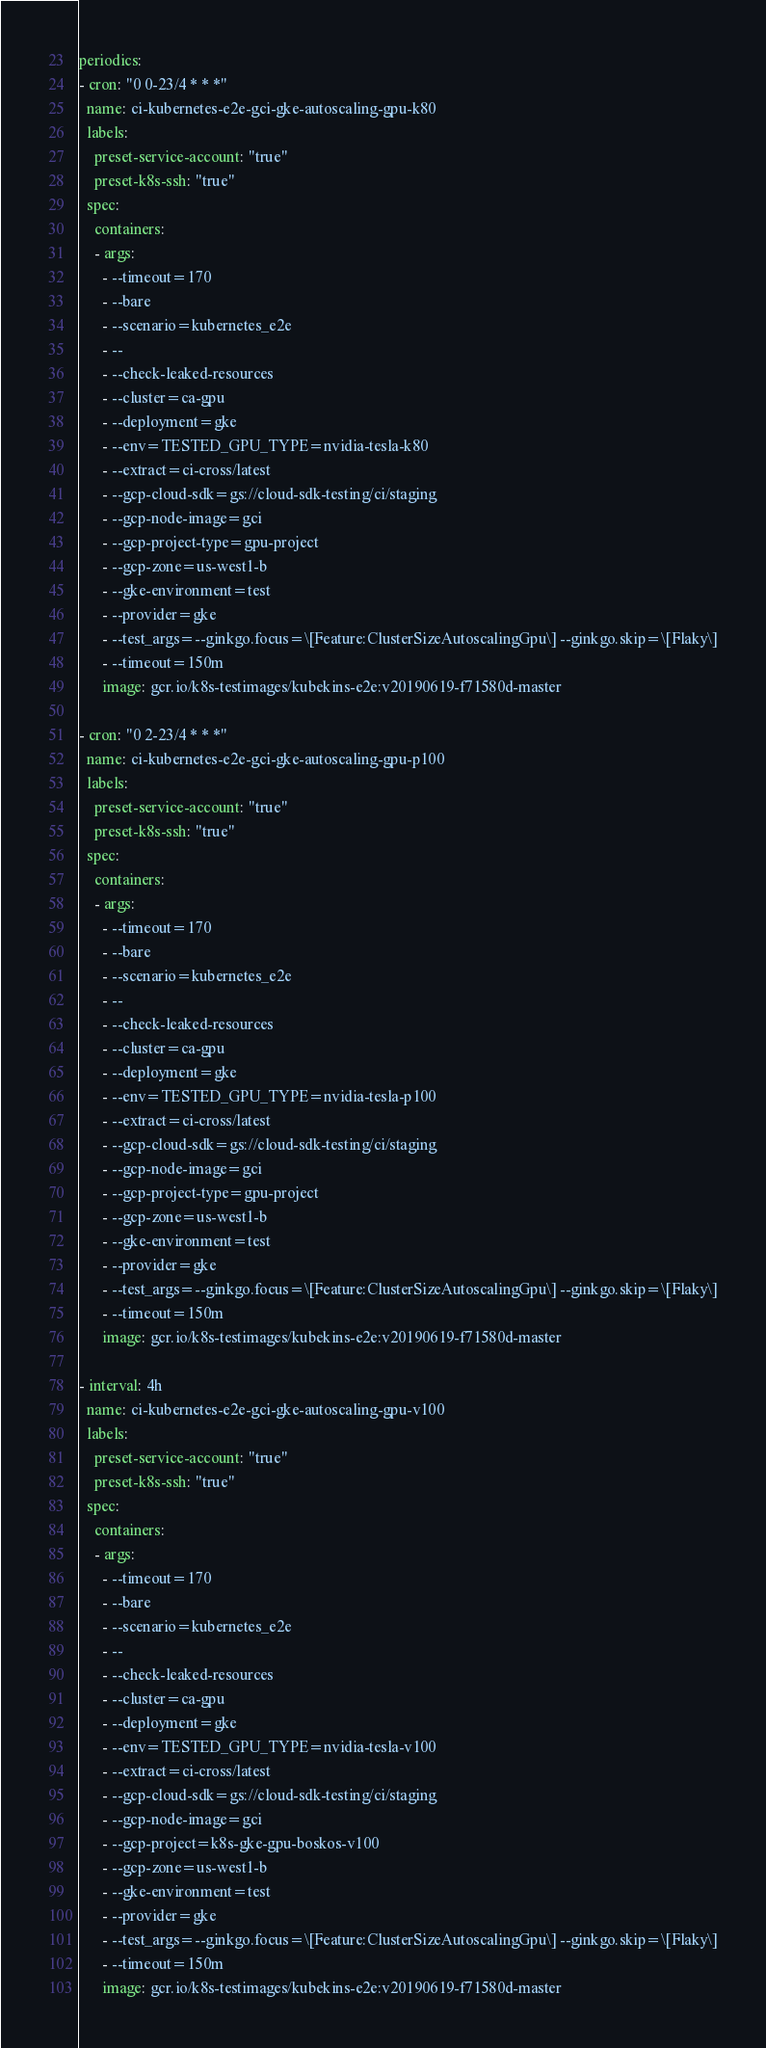<code> <loc_0><loc_0><loc_500><loc_500><_YAML_>periodics:
- cron: "0 0-23/4 * * *"
  name: ci-kubernetes-e2e-gci-gke-autoscaling-gpu-k80
  labels:
    preset-service-account: "true"
    preset-k8s-ssh: "true"
  spec:
    containers:
    - args:
      - --timeout=170
      - --bare
      - --scenario=kubernetes_e2e
      - --
      - --check-leaked-resources
      - --cluster=ca-gpu
      - --deployment=gke
      - --env=TESTED_GPU_TYPE=nvidia-tesla-k80
      - --extract=ci-cross/latest
      - --gcp-cloud-sdk=gs://cloud-sdk-testing/ci/staging
      - --gcp-node-image=gci
      - --gcp-project-type=gpu-project
      - --gcp-zone=us-west1-b
      - --gke-environment=test
      - --provider=gke
      - --test_args=--ginkgo.focus=\[Feature:ClusterSizeAutoscalingGpu\] --ginkgo.skip=\[Flaky\]
      - --timeout=150m
      image: gcr.io/k8s-testimages/kubekins-e2e:v20190619-f71580d-master

- cron: "0 2-23/4 * * *"
  name: ci-kubernetes-e2e-gci-gke-autoscaling-gpu-p100
  labels:
    preset-service-account: "true"
    preset-k8s-ssh: "true"
  spec:
    containers:
    - args:
      - --timeout=170
      - --bare
      - --scenario=kubernetes_e2e
      - --
      - --check-leaked-resources
      - --cluster=ca-gpu
      - --deployment=gke
      - --env=TESTED_GPU_TYPE=nvidia-tesla-p100
      - --extract=ci-cross/latest
      - --gcp-cloud-sdk=gs://cloud-sdk-testing/ci/staging
      - --gcp-node-image=gci
      - --gcp-project-type=gpu-project
      - --gcp-zone=us-west1-b
      - --gke-environment=test
      - --provider=gke
      - --test_args=--ginkgo.focus=\[Feature:ClusterSizeAutoscalingGpu\] --ginkgo.skip=\[Flaky\]
      - --timeout=150m
      image: gcr.io/k8s-testimages/kubekins-e2e:v20190619-f71580d-master

- interval: 4h
  name: ci-kubernetes-e2e-gci-gke-autoscaling-gpu-v100
  labels:
    preset-service-account: "true"
    preset-k8s-ssh: "true"
  spec:
    containers:
    - args:
      - --timeout=170
      - --bare
      - --scenario=kubernetes_e2e
      - --
      - --check-leaked-resources
      - --cluster=ca-gpu
      - --deployment=gke
      - --env=TESTED_GPU_TYPE=nvidia-tesla-v100
      - --extract=ci-cross/latest
      - --gcp-cloud-sdk=gs://cloud-sdk-testing/ci/staging
      - --gcp-node-image=gci
      - --gcp-project=k8s-gke-gpu-boskos-v100
      - --gcp-zone=us-west1-b
      - --gke-environment=test
      - --provider=gke
      - --test_args=--ginkgo.focus=\[Feature:ClusterSizeAutoscalingGpu\] --ginkgo.skip=\[Flaky\]
      - --timeout=150m
      image: gcr.io/k8s-testimages/kubekins-e2e:v20190619-f71580d-master
</code> 